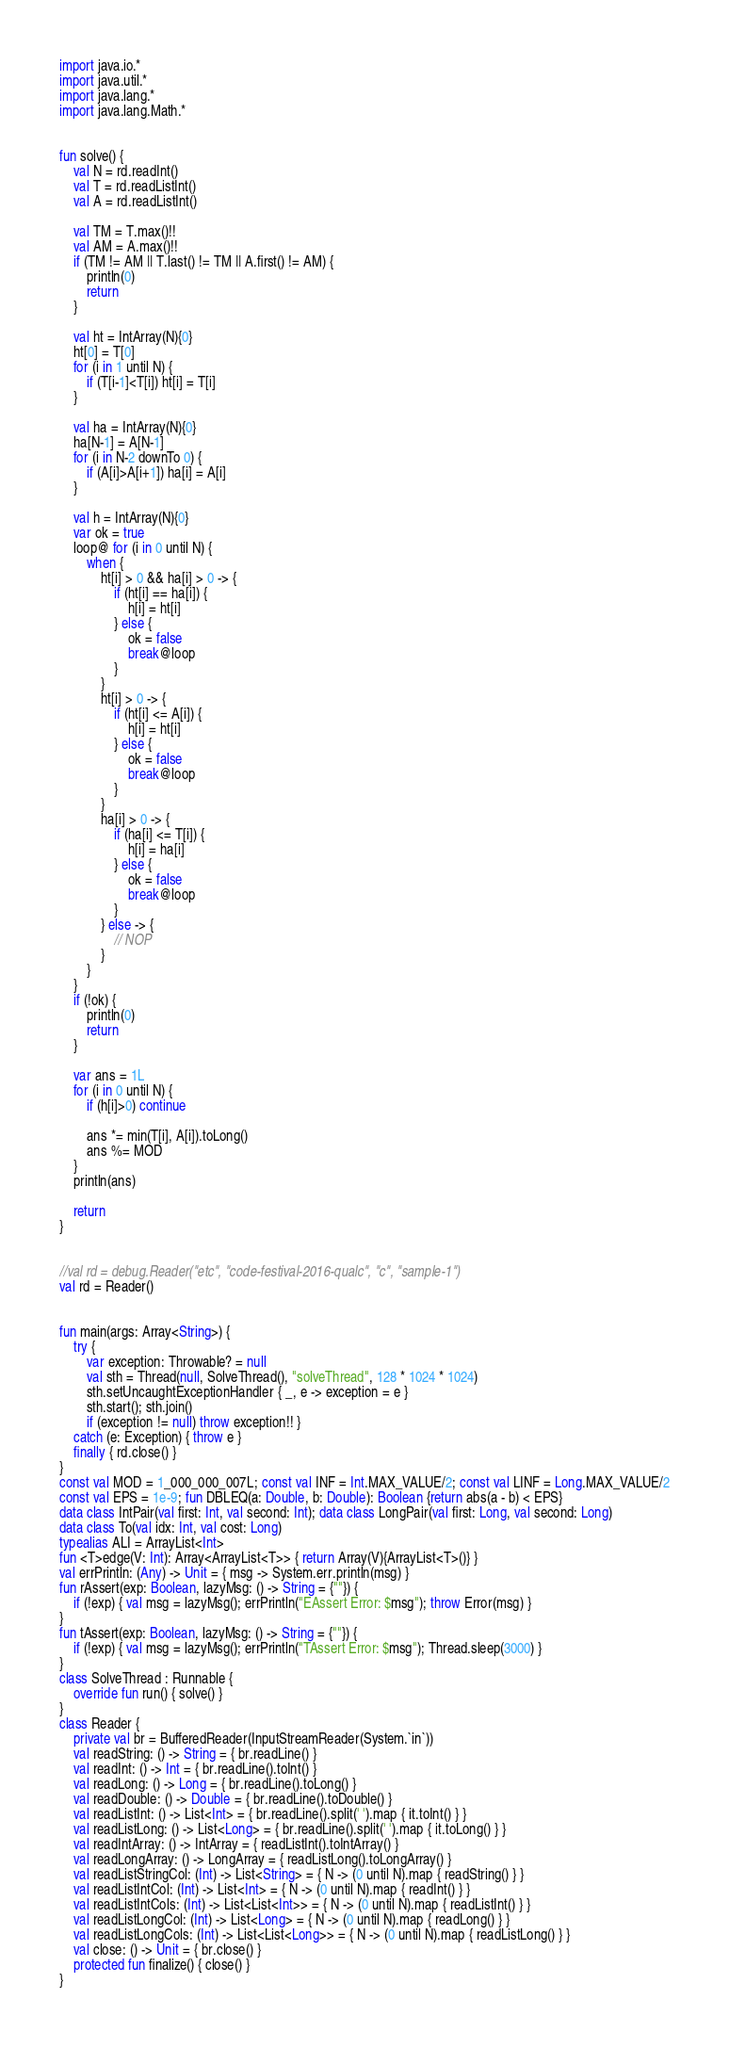<code> <loc_0><loc_0><loc_500><loc_500><_Kotlin_>import java.io.*
import java.util.*
import java.lang.*
import java.lang.Math.*


fun solve() {
    val N = rd.readInt()
    val T = rd.readListInt()
    val A = rd.readListInt()

    val TM = T.max()!!
    val AM = A.max()!!
    if (TM != AM || T.last() != TM || A.first() != AM) {
        println(0)
        return
    }

    val ht = IntArray(N){0}
    ht[0] = T[0]
    for (i in 1 until N) {
        if (T[i-1]<T[i]) ht[i] = T[i]
    }

    val ha = IntArray(N){0}
    ha[N-1] = A[N-1]
    for (i in N-2 downTo 0) {
        if (A[i]>A[i+1]) ha[i] = A[i]
    }

    val h = IntArray(N){0}
    var ok = true
    loop@ for (i in 0 until N) {
        when {
            ht[i] > 0 && ha[i] > 0 -> {
                if (ht[i] == ha[i]) {
                    h[i] = ht[i]
                } else {
                    ok = false
                    break@loop
                }
            }
            ht[i] > 0 -> {
                if (ht[i] <= A[i]) {
                    h[i] = ht[i]
                } else {
                    ok = false
                    break@loop
                }
            }
            ha[i] > 0 -> {
                if (ha[i] <= T[i]) {
                    h[i] = ha[i]
                } else {
                    ok = false
                    break@loop
                }
            } else -> {
                // NOP
            }
        }
    }
    if (!ok) {
        println(0)
        return
    }

    var ans = 1L
    for (i in 0 until N) {
        if (h[i]>0) continue
        
        ans *= min(T[i], A[i]).toLong()
        ans %= MOD
    }
    println(ans)

    return
}


//val rd = debug.Reader("etc", "code-festival-2016-qualc", "c", "sample-1")
val rd = Reader()


fun main(args: Array<String>) {
    try {
        var exception: Throwable? = null
        val sth = Thread(null, SolveThread(), "solveThread", 128 * 1024 * 1024)
        sth.setUncaughtExceptionHandler { _, e -> exception = e }
        sth.start(); sth.join()
        if (exception != null) throw exception!! }
    catch (e: Exception) { throw e }
    finally { rd.close() }
}
const val MOD = 1_000_000_007L; const val INF = Int.MAX_VALUE/2; const val LINF = Long.MAX_VALUE/2
const val EPS = 1e-9; fun DBLEQ(a: Double, b: Double): Boolean {return abs(a - b) < EPS}
data class IntPair(val first: Int, val second: Int); data class LongPair(val first: Long, val second: Long)
data class To(val idx: Int, val cost: Long)
typealias ALI = ArrayList<Int>
fun <T>edge(V: Int): Array<ArrayList<T>> { return Array(V){ArrayList<T>()} }
val errPrintln: (Any) -> Unit = { msg -> System.err.println(msg) }
fun rAssert(exp: Boolean, lazyMsg: () -> String = {""}) {
    if (!exp) { val msg = lazyMsg(); errPrintln("EAssert Error: $msg"); throw Error(msg) }
}
fun tAssert(exp: Boolean, lazyMsg: () -> String = {""}) {
    if (!exp) { val msg = lazyMsg(); errPrintln("TAssert Error: $msg"); Thread.sleep(3000) }
}
class SolveThread : Runnable {
    override fun run() { solve() }
}
class Reader {
    private val br = BufferedReader(InputStreamReader(System.`in`))
    val readString: () -> String = { br.readLine() }
    val readInt: () -> Int = { br.readLine().toInt() }
    val readLong: () -> Long = { br.readLine().toLong() }
    val readDouble: () -> Double = { br.readLine().toDouble() }
    val readListInt: () -> List<Int> = { br.readLine().split(' ').map { it.toInt() } }
    val readListLong: () -> List<Long> = { br.readLine().split(' ').map { it.toLong() } }
    val readIntArray: () -> IntArray = { readListInt().toIntArray() }
    val readLongArray: () -> LongArray = { readListLong().toLongArray() }
    val readListStringCol: (Int) -> List<String> = { N -> (0 until N).map { readString() } }
    val readListIntCol: (Int) -> List<Int> = { N -> (0 until N).map { readInt() } }
    val readListIntCols: (Int) -> List<List<Int>> = { N -> (0 until N).map { readListInt() } }
    val readListLongCol: (Int) -> List<Long> = { N -> (0 until N).map { readLong() } }
    val readListLongCols: (Int) -> List<List<Long>> = { N -> (0 until N).map { readListLong() } }
    val close: () -> Unit = { br.close() }
    protected fun finalize() { close() }
}
</code> 